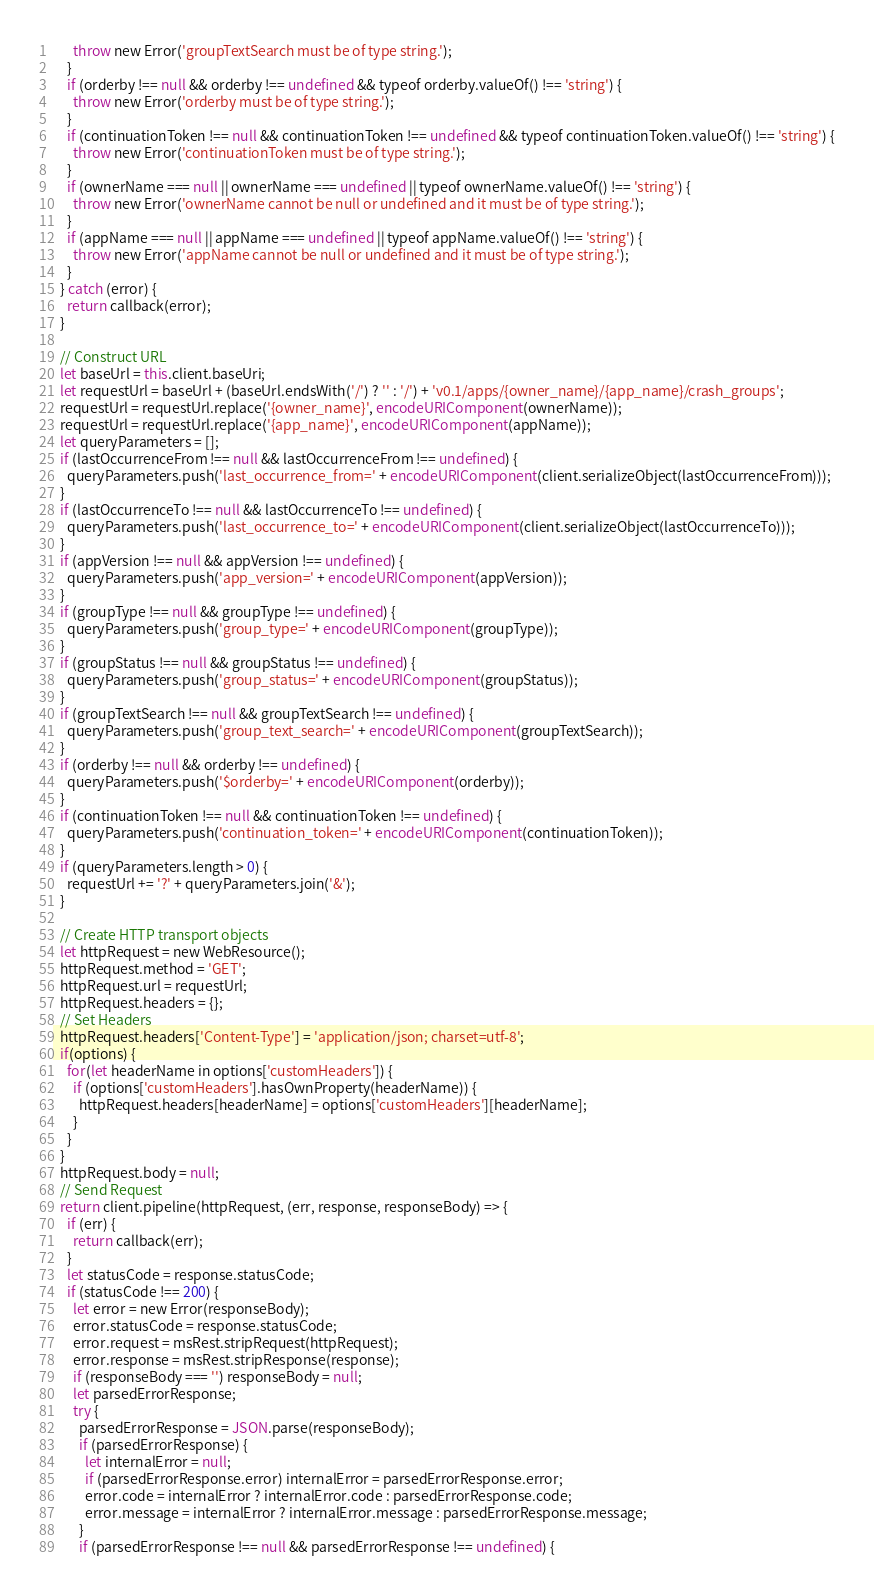<code> <loc_0><loc_0><loc_500><loc_500><_JavaScript_>      throw new Error('groupTextSearch must be of type string.');
    }
    if (orderby !== null && orderby !== undefined && typeof orderby.valueOf() !== 'string') {
      throw new Error('orderby must be of type string.');
    }
    if (continuationToken !== null && continuationToken !== undefined && typeof continuationToken.valueOf() !== 'string') {
      throw new Error('continuationToken must be of type string.');
    }
    if (ownerName === null || ownerName === undefined || typeof ownerName.valueOf() !== 'string') {
      throw new Error('ownerName cannot be null or undefined and it must be of type string.');
    }
    if (appName === null || appName === undefined || typeof appName.valueOf() !== 'string') {
      throw new Error('appName cannot be null or undefined and it must be of type string.');
    }
  } catch (error) {
    return callback(error);
  }

  // Construct URL
  let baseUrl = this.client.baseUri;
  let requestUrl = baseUrl + (baseUrl.endsWith('/') ? '' : '/') + 'v0.1/apps/{owner_name}/{app_name}/crash_groups';
  requestUrl = requestUrl.replace('{owner_name}', encodeURIComponent(ownerName));
  requestUrl = requestUrl.replace('{app_name}', encodeURIComponent(appName));
  let queryParameters = [];
  if (lastOccurrenceFrom !== null && lastOccurrenceFrom !== undefined) {
    queryParameters.push('last_occurrence_from=' + encodeURIComponent(client.serializeObject(lastOccurrenceFrom)));
  }
  if (lastOccurrenceTo !== null && lastOccurrenceTo !== undefined) {
    queryParameters.push('last_occurrence_to=' + encodeURIComponent(client.serializeObject(lastOccurrenceTo)));
  }
  if (appVersion !== null && appVersion !== undefined) {
    queryParameters.push('app_version=' + encodeURIComponent(appVersion));
  }
  if (groupType !== null && groupType !== undefined) {
    queryParameters.push('group_type=' + encodeURIComponent(groupType));
  }
  if (groupStatus !== null && groupStatus !== undefined) {
    queryParameters.push('group_status=' + encodeURIComponent(groupStatus));
  }
  if (groupTextSearch !== null && groupTextSearch !== undefined) {
    queryParameters.push('group_text_search=' + encodeURIComponent(groupTextSearch));
  }
  if (orderby !== null && orderby !== undefined) {
    queryParameters.push('$orderby=' + encodeURIComponent(orderby));
  }
  if (continuationToken !== null && continuationToken !== undefined) {
    queryParameters.push('continuation_token=' + encodeURIComponent(continuationToken));
  }
  if (queryParameters.length > 0) {
    requestUrl += '?' + queryParameters.join('&');
  }

  // Create HTTP transport objects
  let httpRequest = new WebResource();
  httpRequest.method = 'GET';
  httpRequest.url = requestUrl;
  httpRequest.headers = {};
  // Set Headers
  httpRequest.headers['Content-Type'] = 'application/json; charset=utf-8';
  if(options) {
    for(let headerName in options['customHeaders']) {
      if (options['customHeaders'].hasOwnProperty(headerName)) {
        httpRequest.headers[headerName] = options['customHeaders'][headerName];
      }
    }
  }
  httpRequest.body = null;
  // Send Request
  return client.pipeline(httpRequest, (err, response, responseBody) => {
    if (err) {
      return callback(err);
    }
    let statusCode = response.statusCode;
    if (statusCode !== 200) {
      let error = new Error(responseBody);
      error.statusCode = response.statusCode;
      error.request = msRest.stripRequest(httpRequest);
      error.response = msRest.stripResponse(response);
      if (responseBody === '') responseBody = null;
      let parsedErrorResponse;
      try {
        parsedErrorResponse = JSON.parse(responseBody);
        if (parsedErrorResponse) {
          let internalError = null;
          if (parsedErrorResponse.error) internalError = parsedErrorResponse.error;
          error.code = internalError ? internalError.code : parsedErrorResponse.code;
          error.message = internalError ? internalError.message : parsedErrorResponse.message;
        }
        if (parsedErrorResponse !== null && parsedErrorResponse !== undefined) {</code> 